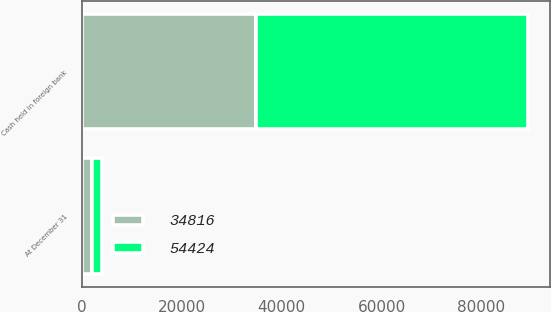<chart> <loc_0><loc_0><loc_500><loc_500><stacked_bar_chart><ecel><fcel>At December 31<fcel>Cash held in foreign bank<nl><fcel>54424<fcel>2016<fcel>54424<nl><fcel>34816<fcel>2015<fcel>34816<nl></chart> 